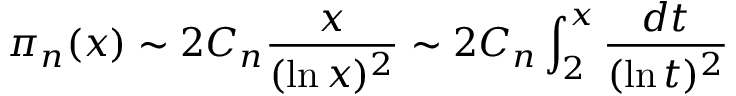Convert formula to latex. <formula><loc_0><loc_0><loc_500><loc_500>\pi _ { n } ( x ) \sim 2 C _ { n } { \frac { x } { ( \ln x ) ^ { 2 } } } \sim 2 C _ { n } \int _ { 2 } ^ { x } { \frac { d t } { ( \ln t ) ^ { 2 } } }</formula> 